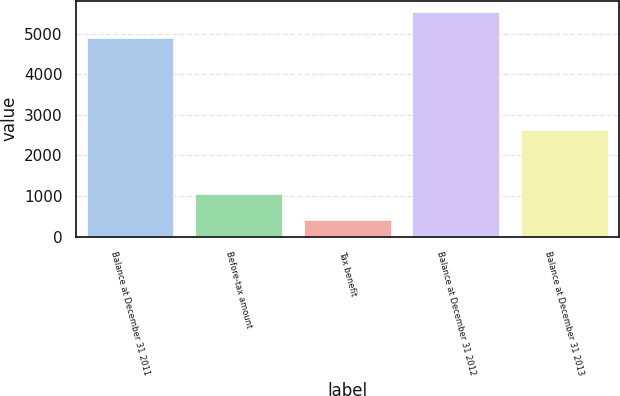Convert chart to OTSL. <chart><loc_0><loc_0><loc_500><loc_500><bar_chart><fcel>Balance at December 31 2011<fcel>Before-tax amount<fcel>Tax benefit<fcel>Balance at December 31 2012<fcel>Balance at December 31 2013<nl><fcel>4879<fcel>1062<fcel>406<fcel>5535<fcel>2629<nl></chart> 